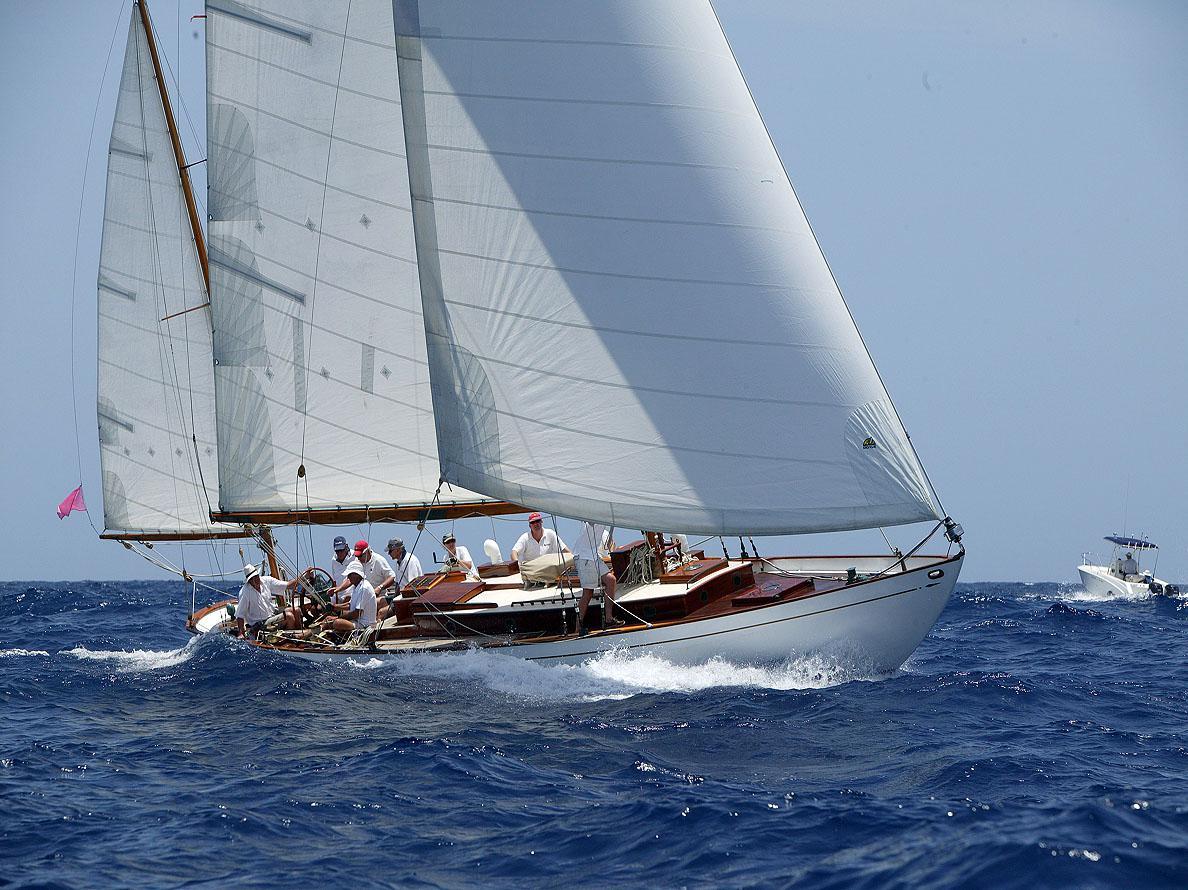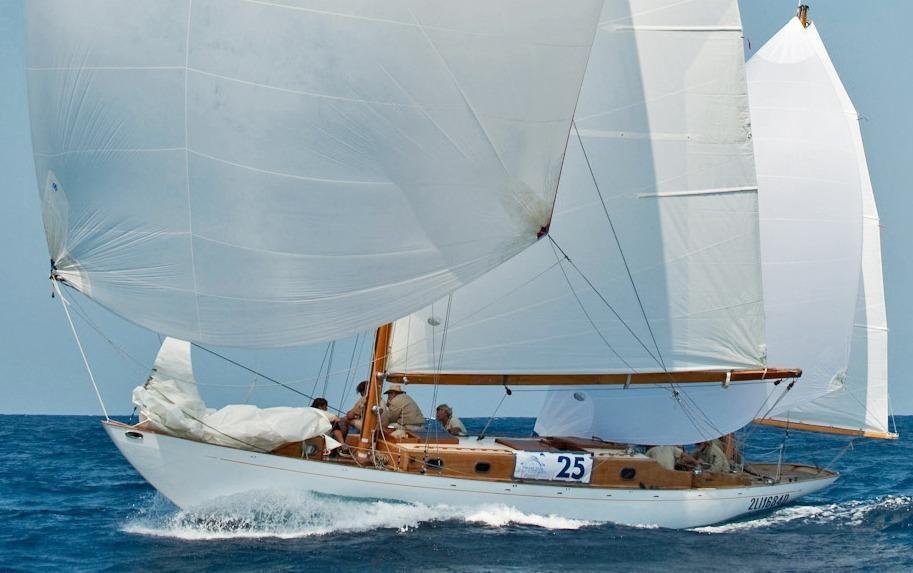The first image is the image on the left, the second image is the image on the right. Analyze the images presented: Is the assertion "There is no more than 1 raised sail in the right image." valid? Answer yes or no. No. The first image is the image on the left, the second image is the image on the right. Evaluate the accuracy of this statement regarding the images: "One of the images has a large group of people all wearing white shirts.". Is it true? Answer yes or no. Yes. 